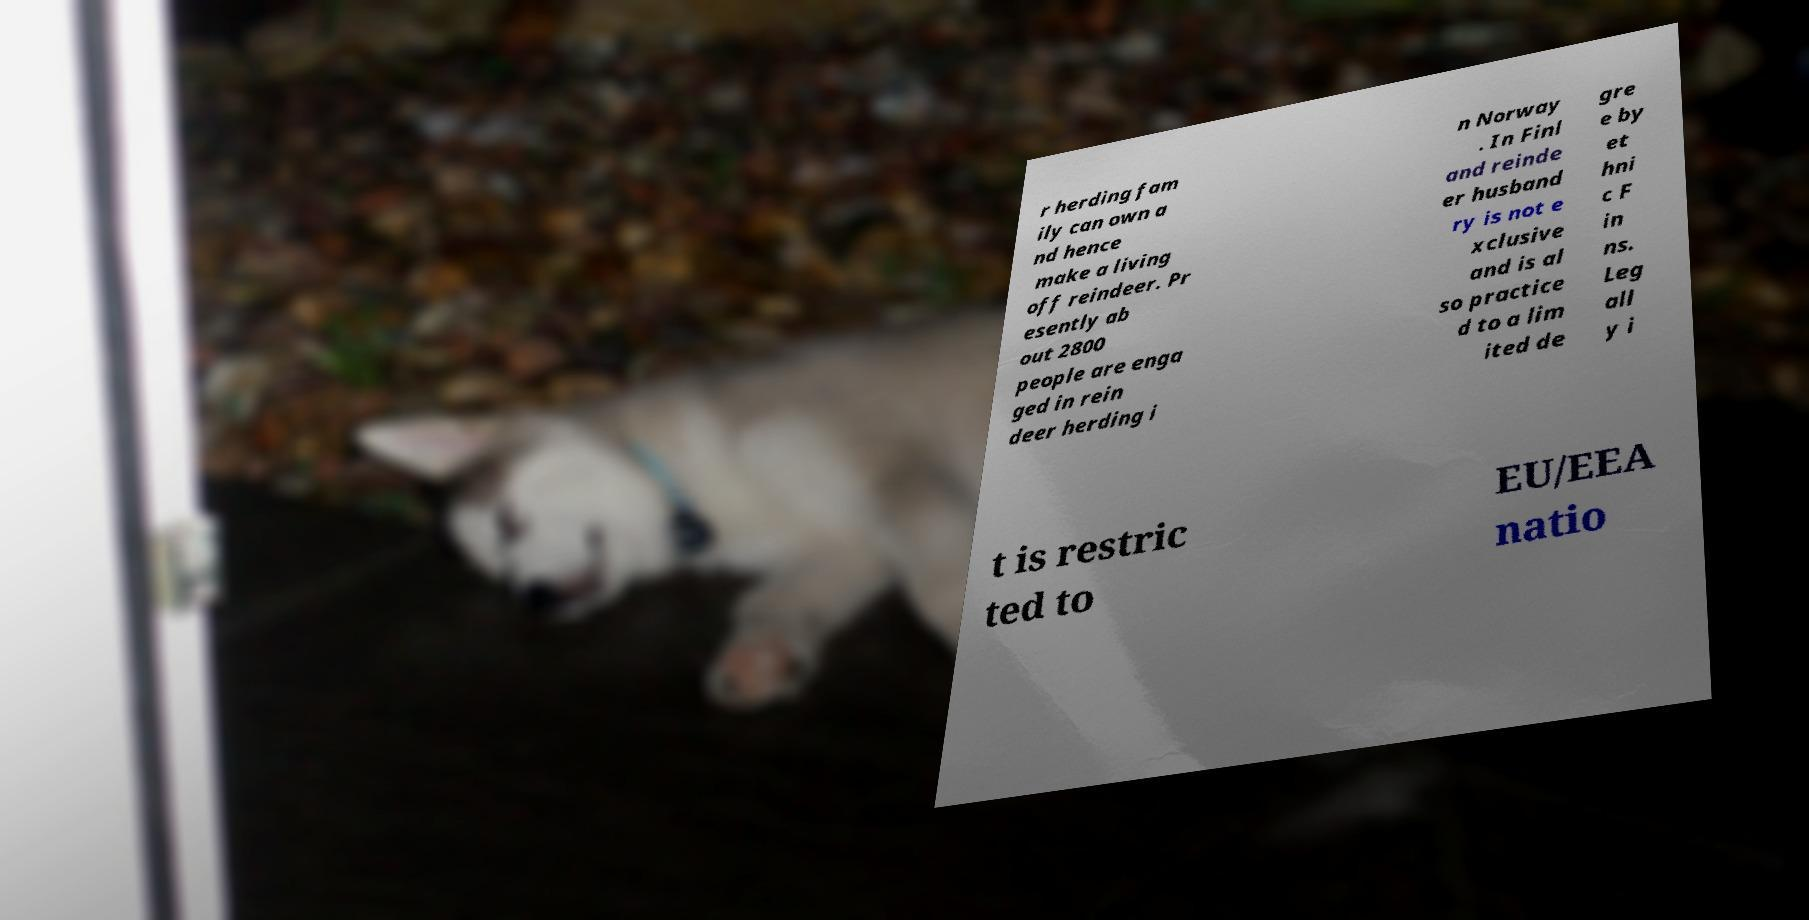Could you assist in decoding the text presented in this image and type it out clearly? r herding fam ily can own a nd hence make a living off reindeer. Pr esently ab out 2800 people are enga ged in rein deer herding i n Norway . In Finl and reinde er husband ry is not e xclusive and is al so practice d to a lim ited de gre e by et hni c F in ns. Leg all y i t is restric ted to EU/EEA natio 